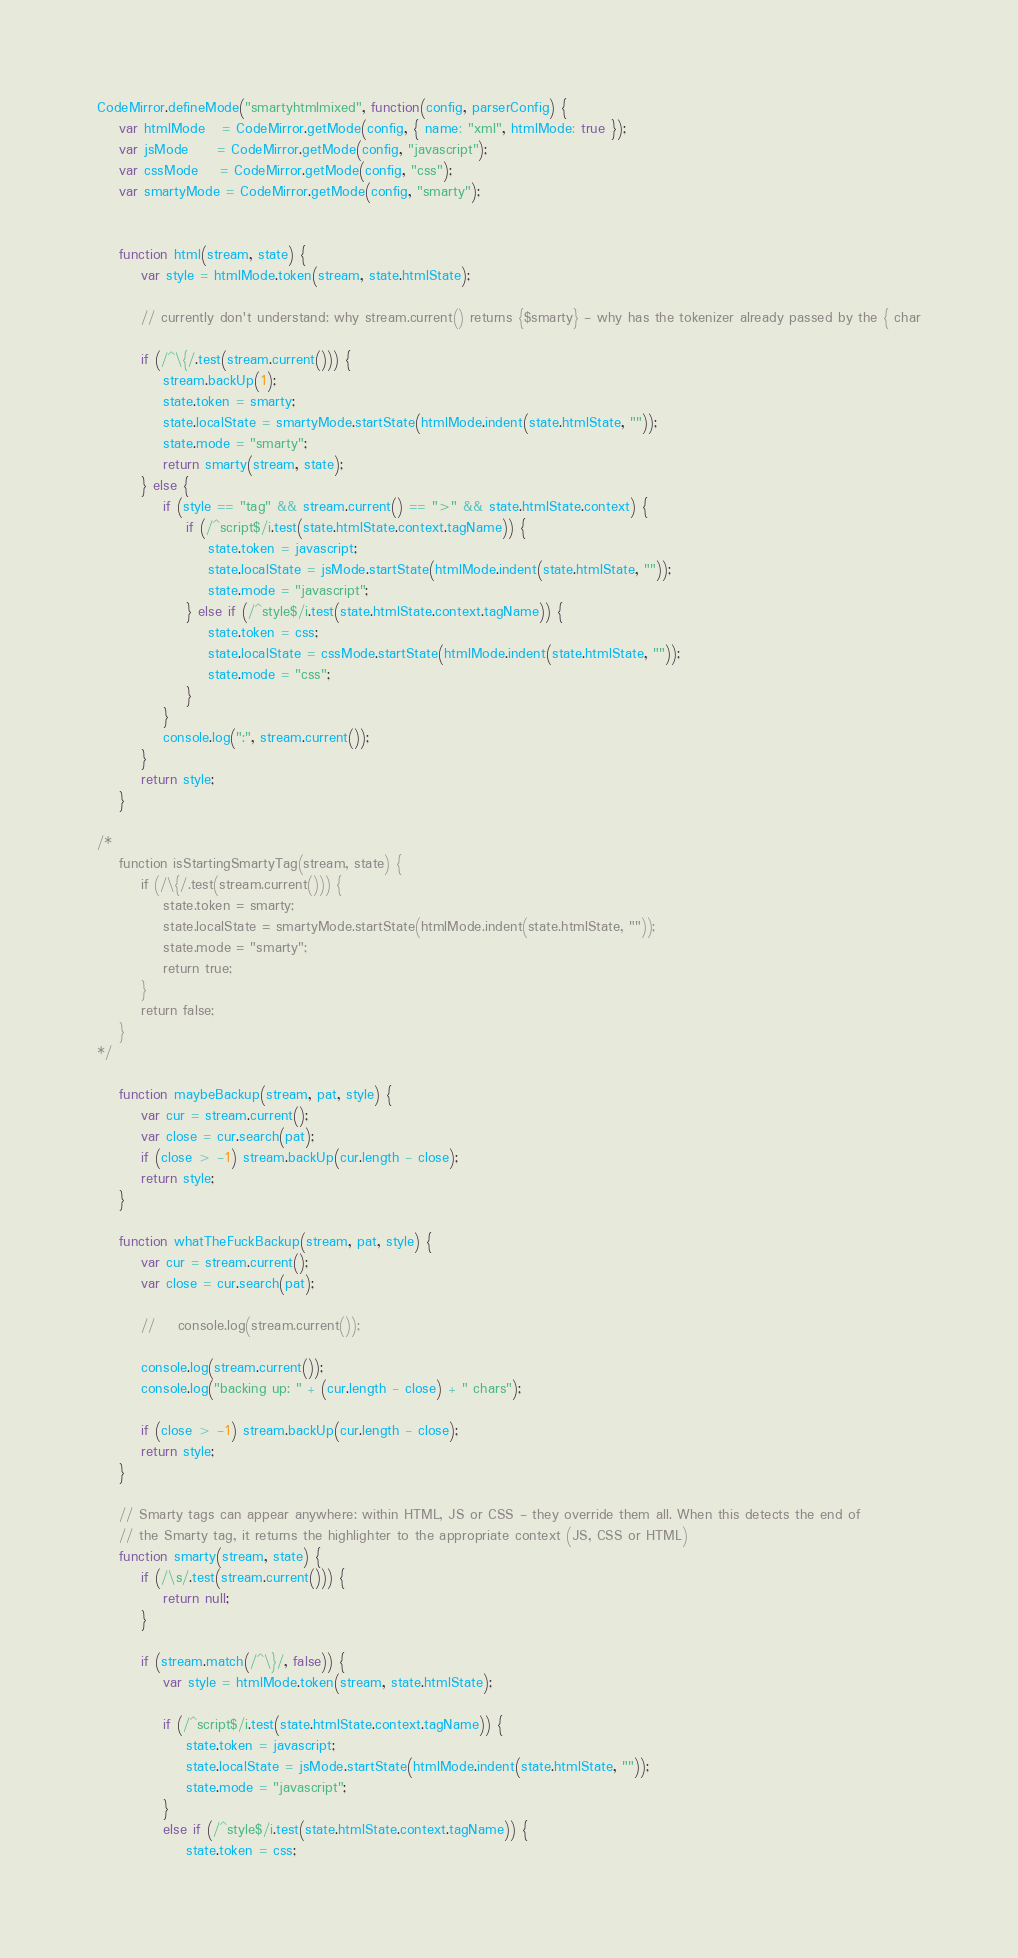<code> <loc_0><loc_0><loc_500><loc_500><_JavaScript_>CodeMirror.defineMode("smartyhtmlmixed", function(config, parserConfig) {
	var htmlMode   = CodeMirror.getMode(config, { name: "xml", htmlMode: true });
	var jsMode     = CodeMirror.getMode(config, "javascript");
	var cssMode    = CodeMirror.getMode(config, "css");
	var smartyMode = CodeMirror.getMode(config, "smarty");


	function html(stream, state) {
		var style = htmlMode.token(stream, state.htmlState);

		// currently don't understand: why stream.current() returns {$smarty} - why has the tokenizer already passed by the { char

		if (/^\{/.test(stream.current())) {
			stream.backUp(1);
			state.token = smarty;
			state.localState = smartyMode.startState(htmlMode.indent(state.htmlState, ""));
			state.mode = "smarty";
			return smarty(stream, state);
		} else {
			if (style == "tag" && stream.current() == ">" && state.htmlState.context) {
				if (/^script$/i.test(state.htmlState.context.tagName)) {
					state.token = javascript;
					state.localState = jsMode.startState(htmlMode.indent(state.htmlState, ""));
					state.mode = "javascript";
				} else if (/^style$/i.test(state.htmlState.context.tagName)) {
					state.token = css;
					state.localState = cssMode.startState(htmlMode.indent(state.htmlState, ""));
					state.mode = "css";
				}
			}
			console.log(":", stream.current());
		}
		return style;
	}

/*
	function isStartingSmartyTag(stream, state) {
		if (/\{/.test(stream.current())) {
			state.token = smarty;
			state.localState = smartyMode.startState(htmlMode.indent(state.htmlState, ""));
			state.mode = "smarty";
			return true;
		}
		return false;
	}
*/

	function maybeBackup(stream, pat, style) {
		var cur = stream.current();
		var close = cur.search(pat);
		if (close > -1) stream.backUp(cur.length - close);
		return style;
	}

	function whatTheFuckBackup(stream, pat, style) {
		var cur = stream.current();
		var close = cur.search(pat);

		//    console.log(stream.current());

		console.log(stream.current());
		console.log("backing up: " + (cur.length - close) + " chars");

		if (close > -1) stream.backUp(cur.length - close);
		return style;
	}

	// Smarty tags can appear anywhere: within HTML, JS or CSS - they override them all. When this detects the end of
	// the Smarty tag, it returns the highlighter to the appropriate context (JS, CSS or HTML)
	function smarty(stream, state) {
		if (/\s/.test(stream.current())) {
			return null;
		}

		if (stream.match(/^\}/, false)) {
			var style = htmlMode.token(stream, state.htmlState);

			if (/^script$/i.test(state.htmlState.context.tagName)) {
				state.token = javascript;
				state.localState = jsMode.startState(htmlMode.indent(state.htmlState, ""));
				state.mode = "javascript";
			}
			else if (/^style$/i.test(state.htmlState.context.tagName)) {
				state.token = css;</code> 